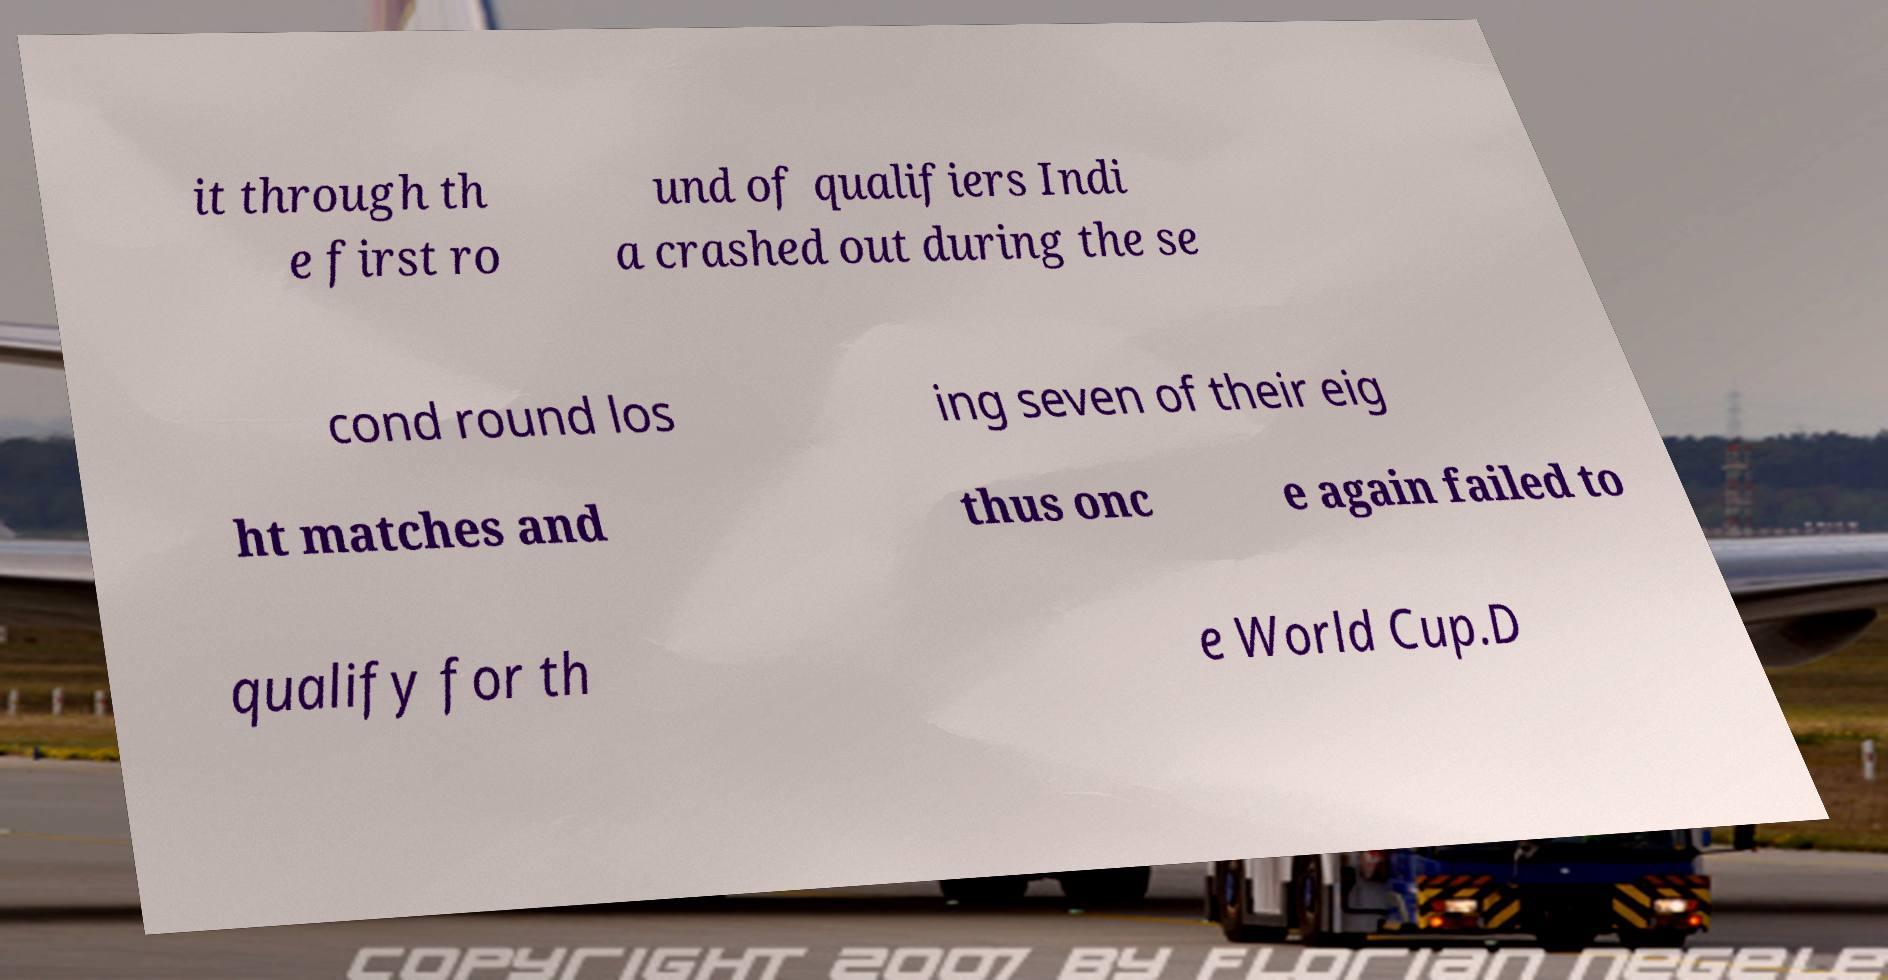I need the written content from this picture converted into text. Can you do that? it through th e first ro und of qualifiers Indi a crashed out during the se cond round los ing seven of their eig ht matches and thus onc e again failed to qualify for th e World Cup.D 